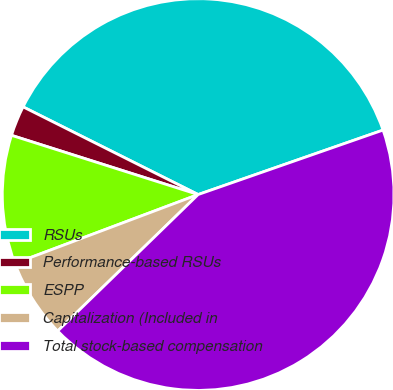Convert chart to OTSL. <chart><loc_0><loc_0><loc_500><loc_500><pie_chart><fcel>RSUs<fcel>Performance-based RSUs<fcel>ESPP<fcel>Capitalization (Included in<fcel>Total stock-based compensation<nl><fcel>37.27%<fcel>2.5%<fcel>10.61%<fcel>6.55%<fcel>43.07%<nl></chart> 